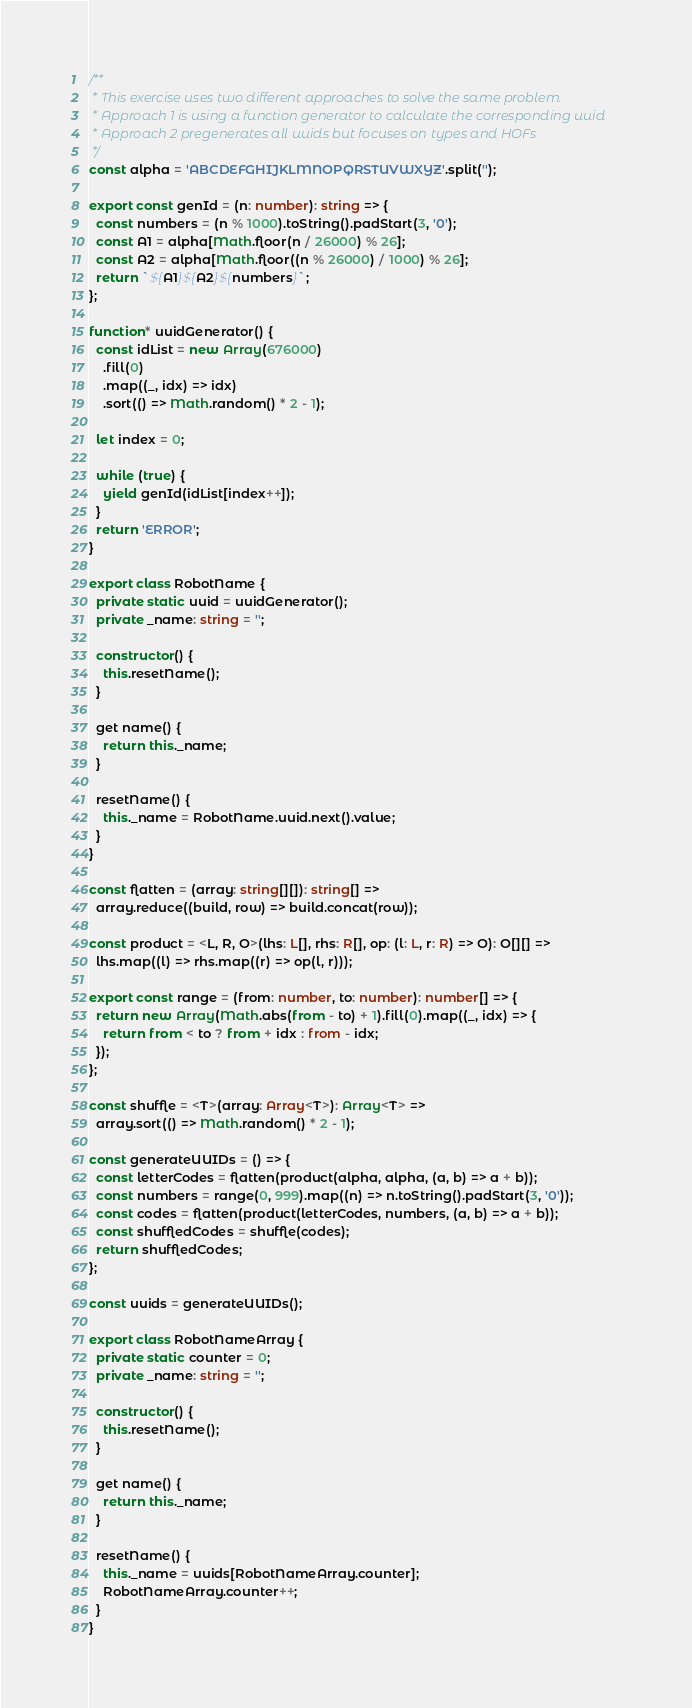<code> <loc_0><loc_0><loc_500><loc_500><_TypeScript_>/**
 * This exercise uses two different approaches to solve the same problem.
 * Approach 1 is using a function generator to calculate the corresponding uuid
 * Approach 2 pregenerates all uuids but focuses on types and HOFs
 */
const alpha = 'ABCDEFGHIJKLMNOPQRSTUVWXYZ'.split('');

export const genId = (n: number): string => {
  const numbers = (n % 1000).toString().padStart(3, '0');
  const A1 = alpha[Math.floor(n / 26000) % 26];
  const A2 = alpha[Math.floor((n % 26000) / 1000) % 26];
  return `${A1}${A2}${numbers}`;
};

function* uuidGenerator() {
  const idList = new Array(676000)
    .fill(0)
    .map((_, idx) => idx)
    .sort(() => Math.random() * 2 - 1);

  let index = 0;

  while (true) {
    yield genId(idList[index++]);
  }
  return 'ERROR';
}

export class RobotName {
  private static uuid = uuidGenerator();
  private _name: string = '';

  constructor() {
    this.resetName();
  }

  get name() {
    return this._name;
  }

  resetName() {
    this._name = RobotName.uuid.next().value;
  }
}

const flatten = (array: string[][]): string[] =>
  array.reduce((build, row) => build.concat(row));

const product = <L, R, O>(lhs: L[], rhs: R[], op: (l: L, r: R) => O): O[][] =>
  lhs.map((l) => rhs.map((r) => op(l, r)));

export const range = (from: number, to: number): number[] => {
  return new Array(Math.abs(from - to) + 1).fill(0).map((_, idx) => {
    return from < to ? from + idx : from - idx;
  });
};

const shuffle = <T>(array: Array<T>): Array<T> =>
  array.sort(() => Math.random() * 2 - 1);

const generateUUIDs = () => {
  const letterCodes = flatten(product(alpha, alpha, (a, b) => a + b));
  const numbers = range(0, 999).map((n) => n.toString().padStart(3, '0'));
  const codes = flatten(product(letterCodes, numbers, (a, b) => a + b));
  const shuffledCodes = shuffle(codes);
  return shuffledCodes;
};

const uuids = generateUUIDs();

export class RobotNameArray {
  private static counter = 0;
  private _name: string = '';

  constructor() {
    this.resetName();
  }

  get name() {
    return this._name;
  }

  resetName() {
    this._name = uuids[RobotNameArray.counter];
    RobotNameArray.counter++;
  }
}
</code> 